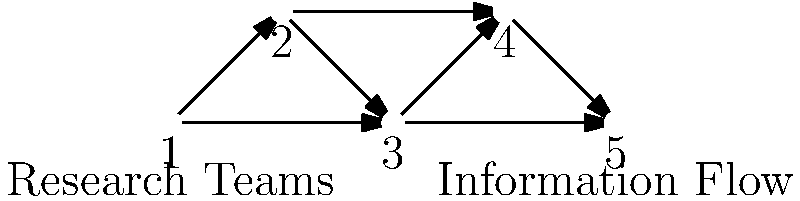In a large-scale collaborative research project, information flows between research teams as shown in the directed graph. Each node represents a team, and edges represent information flow. What is the minimum number of teams that, if removed, would completely disrupt the flow of information from Team 1 to Team 5? Justify your answer using graph theory concepts. To solve this problem, we need to apply the concept of minimum cut in graph theory. Here's a step-by-step approach:

1. Identify the source and sink: 
   - Source (s): Team 1
   - Sink (t): Team 5

2. Analyze possible paths from source to sink:
   - Path 1: 1 → 2 → 3 → 4 → 5
   - Path 2: 1 → 2 → 5
   - Path 3: 1 → 3 → 4 → 5

3. Find the minimum cut:
   - A cut is a set of vertices that, when removed, disconnects the source from the sink.
   - The minimum cut is the smallest such set.

4. Identify potential cuts:
   - Removing team 2 and 3 disconnects all paths.
   - Removing team 2 and 4 also disconnects all paths.

5. Verify that no single team removal can disconnect all paths:
   - Removing only team 2 leaves path 1 → 3 → 4 → 5
   - Removing only team 3 leaves path 1 → 2 → 5
   - Removing only team 4 leaves path 1 → 2 → 5

6. Conclude:
   The minimum number of teams to remove is 2. This represents the minimum cut in the graph, which is the smallest set of vertices whose removal disconnects the source from the sink.
Answer: 2 teams 